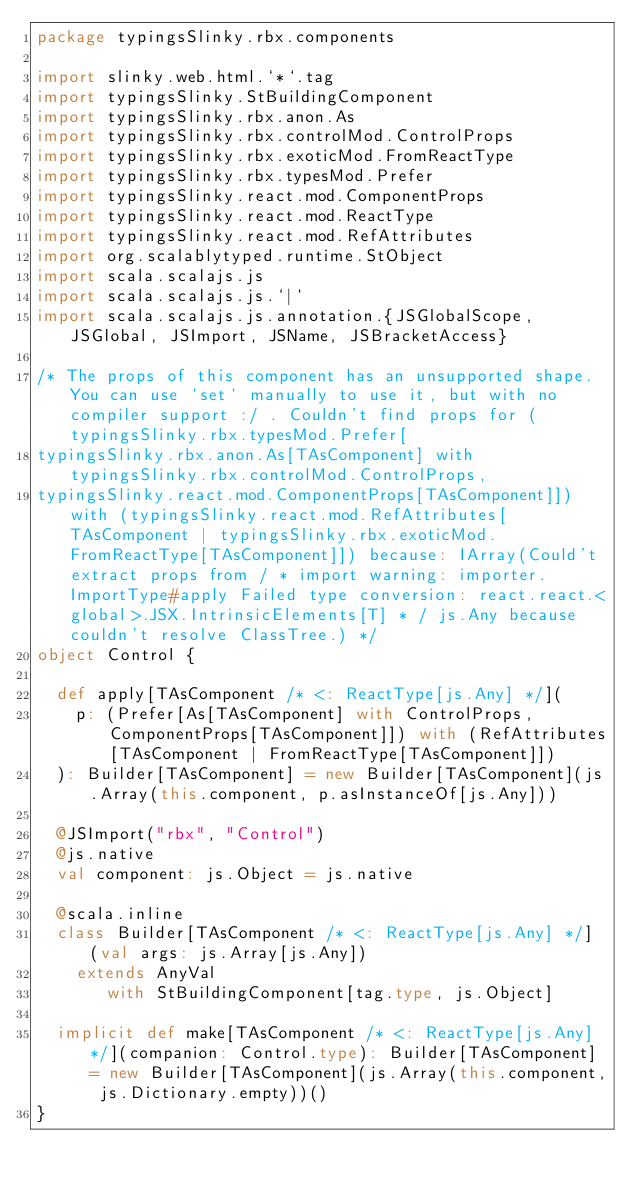Convert code to text. <code><loc_0><loc_0><loc_500><loc_500><_Scala_>package typingsSlinky.rbx.components

import slinky.web.html.`*`.tag
import typingsSlinky.StBuildingComponent
import typingsSlinky.rbx.anon.As
import typingsSlinky.rbx.controlMod.ControlProps
import typingsSlinky.rbx.exoticMod.FromReactType
import typingsSlinky.rbx.typesMod.Prefer
import typingsSlinky.react.mod.ComponentProps
import typingsSlinky.react.mod.ReactType
import typingsSlinky.react.mod.RefAttributes
import org.scalablytyped.runtime.StObject
import scala.scalajs.js
import scala.scalajs.js.`|`
import scala.scalajs.js.annotation.{JSGlobalScope, JSGlobal, JSImport, JSName, JSBracketAccess}

/* The props of this component has an unsupported shape. You can use `set` manually to use it, but with no compiler support :/ . Couldn't find props for (typingsSlinky.rbx.typesMod.Prefer[
typingsSlinky.rbx.anon.As[TAsComponent] with typingsSlinky.rbx.controlMod.ControlProps, 
typingsSlinky.react.mod.ComponentProps[TAsComponent]]) with (typingsSlinky.react.mod.RefAttributes[TAsComponent | typingsSlinky.rbx.exoticMod.FromReactType[TAsComponent]]) because: IArray(Could't extract props from / * import warning: importer.ImportType#apply Failed type conversion: react.react.<global>.JSX.IntrinsicElements[T] * / js.Any because couldn't resolve ClassTree.) */
object Control {
  
  def apply[TAsComponent /* <: ReactType[js.Any] */](
    p: (Prefer[As[TAsComponent] with ControlProps, ComponentProps[TAsComponent]]) with (RefAttributes[TAsComponent | FromReactType[TAsComponent]])
  ): Builder[TAsComponent] = new Builder[TAsComponent](js.Array(this.component, p.asInstanceOf[js.Any]))
  
  @JSImport("rbx", "Control")
  @js.native
  val component: js.Object = js.native
  
  @scala.inline
  class Builder[TAsComponent /* <: ReactType[js.Any] */] (val args: js.Array[js.Any])
    extends AnyVal
       with StBuildingComponent[tag.type, js.Object]
  
  implicit def make[TAsComponent /* <: ReactType[js.Any] */](companion: Control.type): Builder[TAsComponent] = new Builder[TAsComponent](js.Array(this.component, js.Dictionary.empty))()
}
</code> 